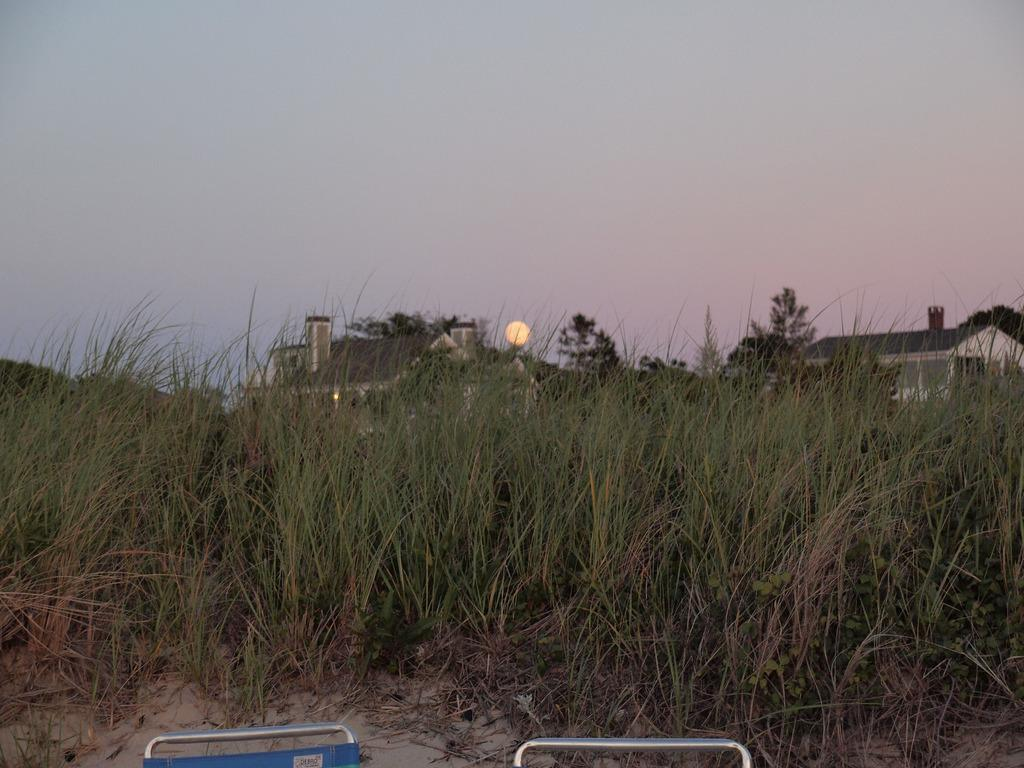What type of furniture is located at the bottom of the image? There are chairs at the bottom of the image. What type of vegetation is visible in the image? There is grass visible in the image. What can be seen in the background of the image? There are houses and the sun visible in the background of the image. What else is visible in the background of the image? The sky is visible in the background of the image. What type of event is taking place in the image? There is no event visible in the image; it shows chairs, grass, houses, the sun, and the sky. Can you tell me how many bodies are present in the image? There are no bodies present in the image; it features chairs, grass, houses, the sun, and the sky. 